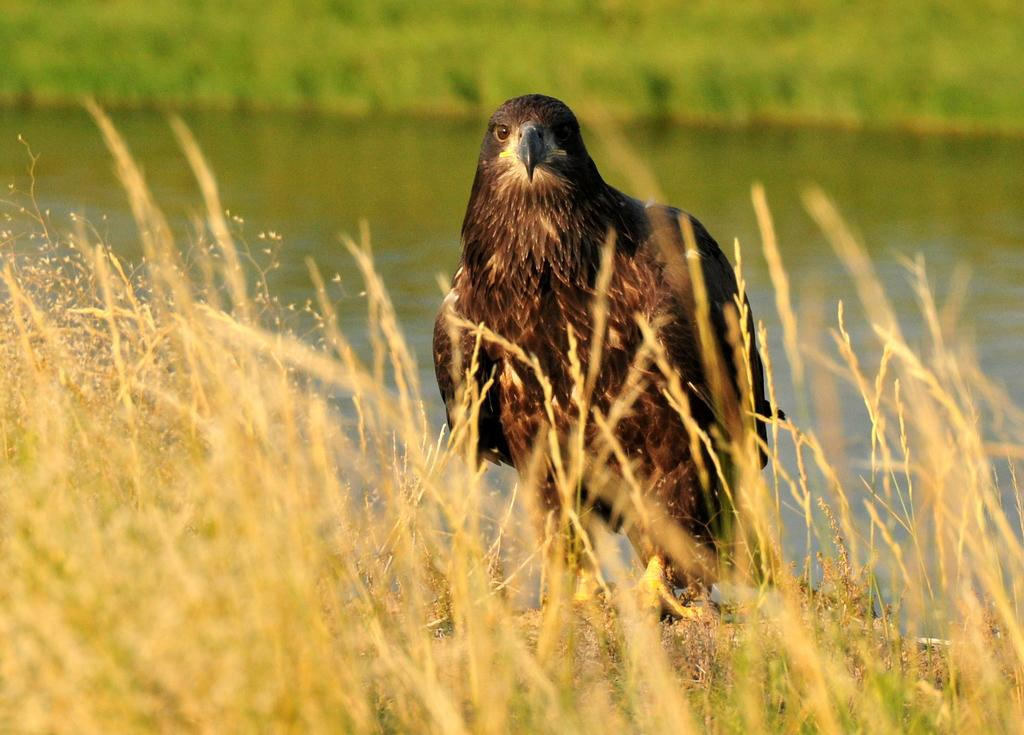What type of animal can be seen in the image? There is a bird in the image. What type of vegetation is present in the image? There is grass in the image. What other element can be seen in the image besides the bird and grass? There is water in the image. Where is the bird's uncle in the image? There is no mention of an uncle or any other family members in the image, so it cannot be determined where the bird's uncle might be. 